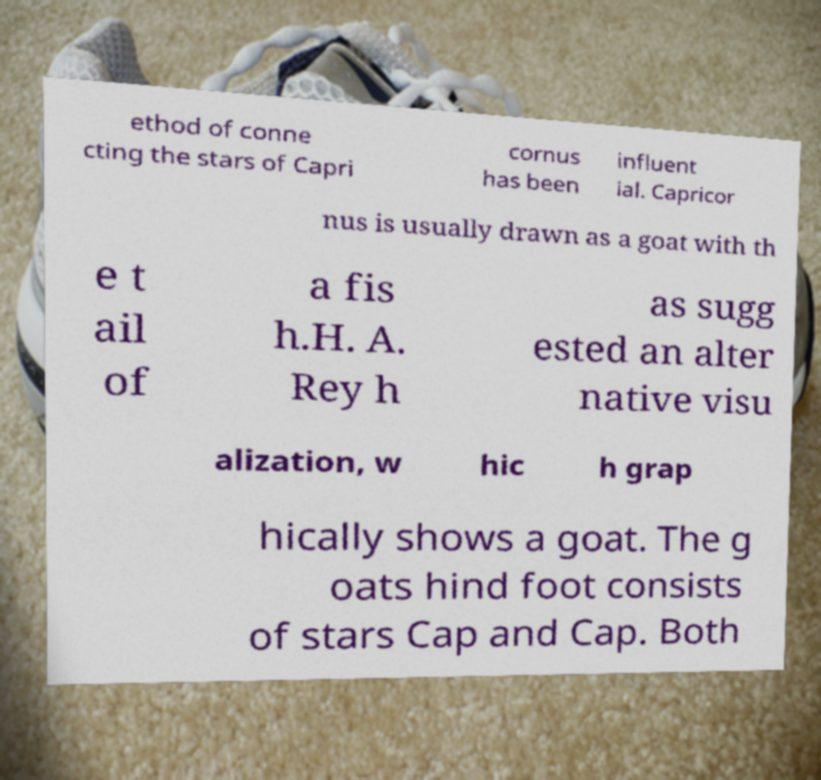Can you read and provide the text displayed in the image?This photo seems to have some interesting text. Can you extract and type it out for me? ethod of conne cting the stars of Capri cornus has been influent ial. Capricor nus is usually drawn as a goat with th e t ail of a fis h.H. A. Rey h as sugg ested an alter native visu alization, w hic h grap hically shows a goat. The g oats hind foot consists of stars Cap and Cap. Both 